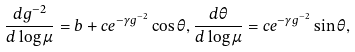Convert formula to latex. <formula><loc_0><loc_0><loc_500><loc_500>\frac { d g ^ { - 2 } } { d \log \mu } = b + c e ^ { - \gamma g ^ { - 2 } } \cos \theta , \frac { d \theta } { d \log \mu } = c e ^ { - \gamma g ^ { - 2 } } \sin \theta ,</formula> 